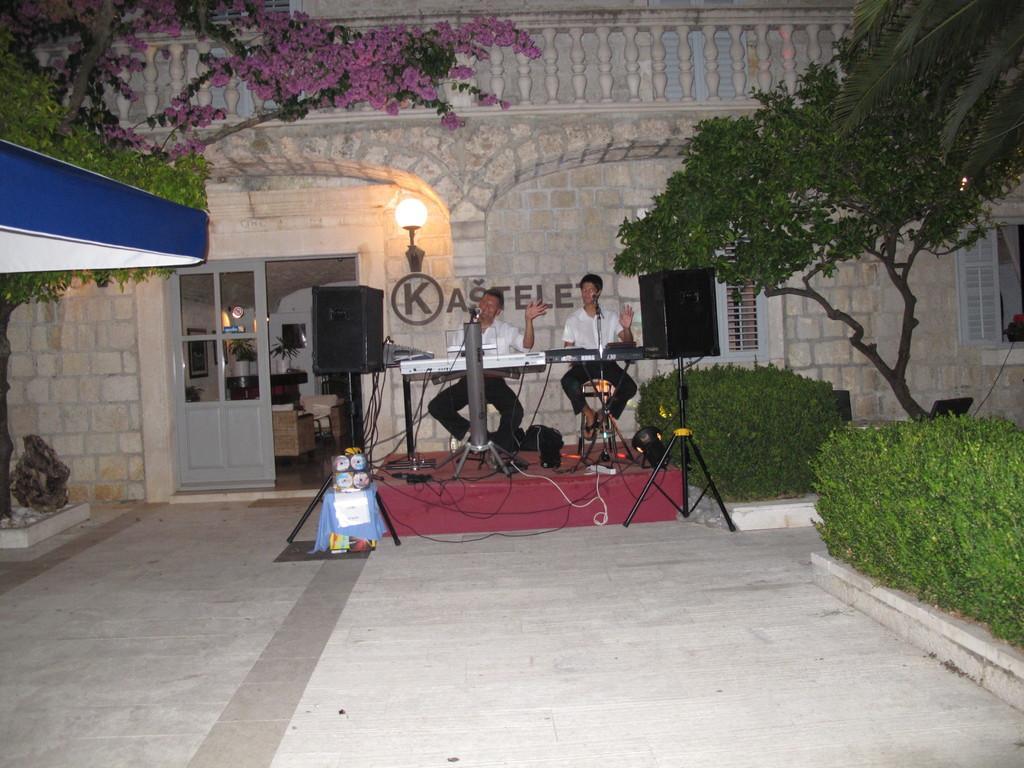Can you describe this image briefly? In this image I can see the ground, the stage, few speaker, few wires, few musical instruments, two persons wearing black and white colored dresses sitting in front of the musical instruments, few trees which are green in color, few flowers which are pink in color, a light and a building. 